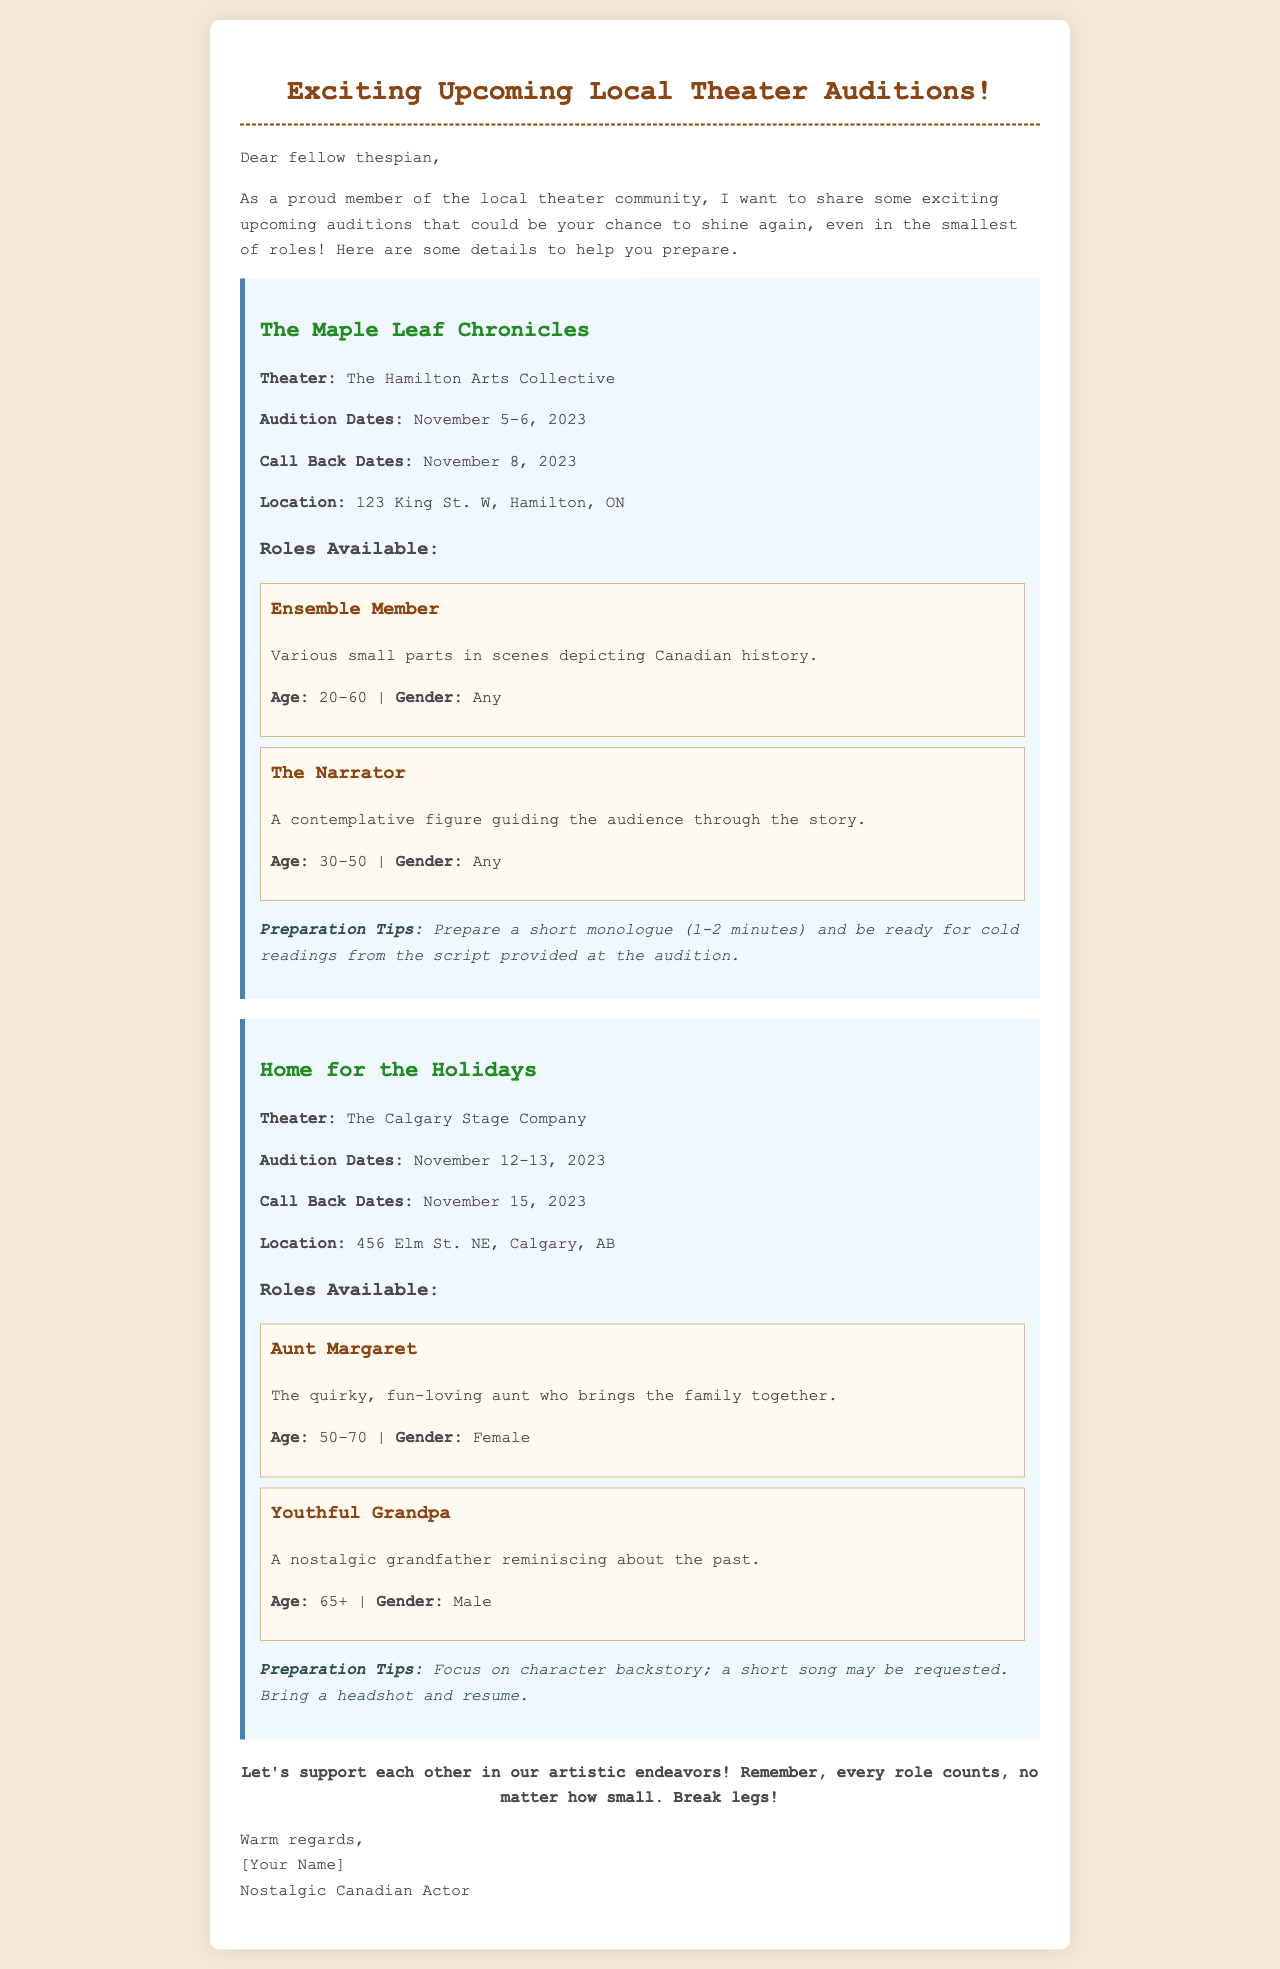What is the name of the first play? The name of the first play listed is at the beginning of the audition section for The Hamilton Arts Collective.
Answer: The Maple Leaf Chronicles What are the audition dates for "Home for the Holidays"? The audition dates for "Home for the Holidays" are specified in the section dedicated to The Calgary Stage Company.
Answer: November 12-13, 2023 What role requires a headshot and resume? The role's preparation section for "Home for the Holidays" mentions bringing a headshot and resume.
Answer: Aunt Margaret How old should an actor be to audition for The Narrator? The age requirements for The Narrator are listed in the roles available for The Maple Leaf Chronicles.
Answer: 30-50 What is one of the preparation tips for "The Maple Leaf Chronicles"? The preparation tips for The Maple Leaf Chronicles detail what actors should prepare for the audition.
Answer: Prepare a short monologue How many roles are available for "The Maple Leaf Chronicles"? Counting the roles listed under The Maple Leaf Chronicles section provides the total.
Answer: 2 What is the closing remark in the email? The last paragraph contains a supportive message to fellow actors.
Answer: Break legs! 